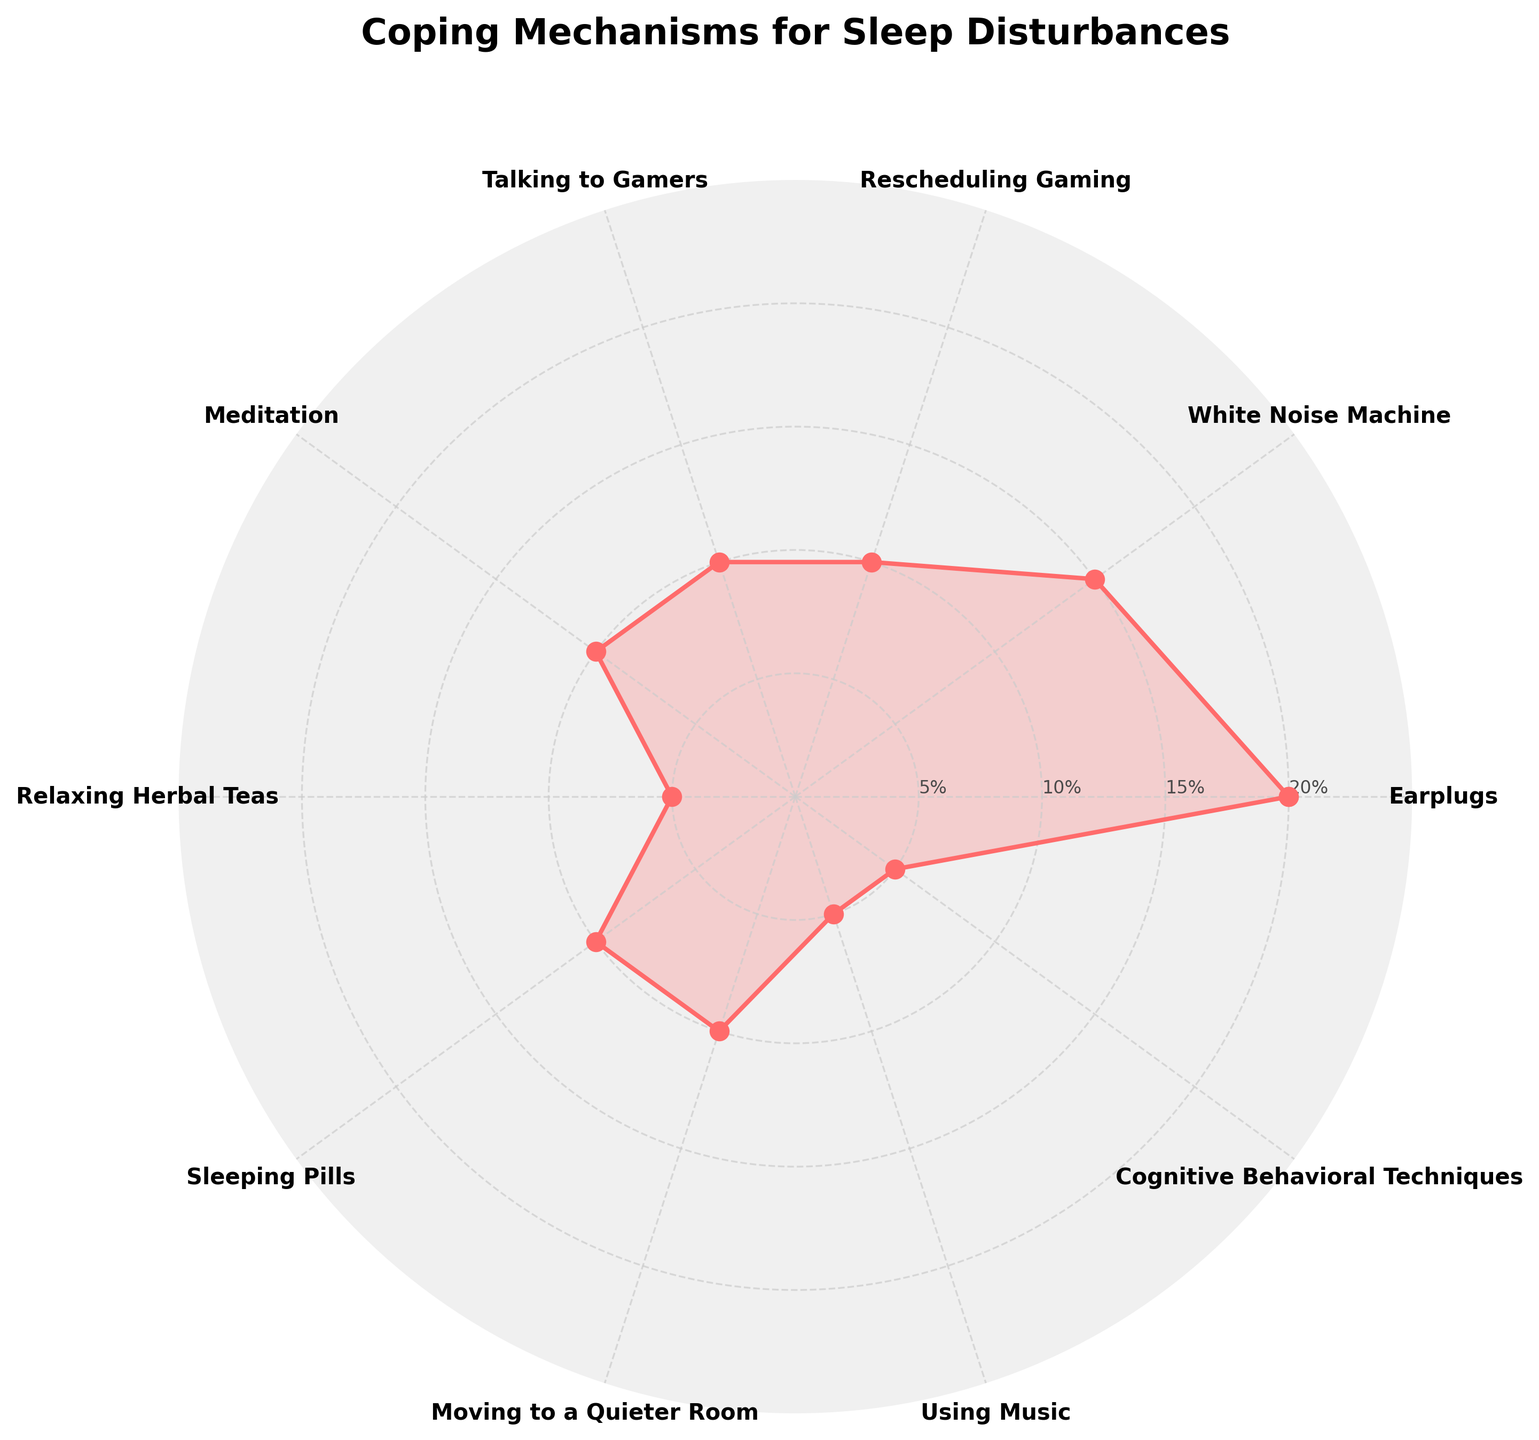What is the title of the chart? The title is typically placed at the top of the chart in a larger font. Reading it directly can provide this information.
Answer: Coping Mechanisms for Sleep Disturbances How many coping mechanisms are listed? The chart lists each coping mechanism around the polar plot area. Counting each labeled category directly answers this question.
Answer: 10 What coping mechanism has the highest percentage? Looking at the data points on the chart's outermost ring shows which coping mechanism reaches the highest value.
Answer: Earplugs Which coping mechanisms have a percentage of 10%? By checking the radial position where values intersect the 10% ring, we identify the corresponding categories.
Answer: Rescheduling Gaming, Talking to Gamers, Meditation, Sleeping Pills, Moving to a Quieter Room What is the combined percentage for White Noise Machine and Meditation? Adding percentages from the chart for White Noise Machine (15%) and Meditation (10%).
Answer: 25% Which coping mechanism is more commonly used: Rescheduling Gaming or Using Music? Comparing the percentage values, Rescheduling Gaming is 10%, and Using Music is 5%, indicating which is greater.
Answer: Rescheduling Gaming What is the average percentage of all coping mechanisms? Summing all the percentage values and then dividing by the number of coping mechanisms (10). (20+15+10+10+10+5+10+10+5+5)/10 = 100/10 = 10.
Answer: 10% What coping mechanisms fall into the range of 5% to 10%? Reviewing each category plotted within this range of radial values identifies the relevant coping mechanisms.
Answer: Meditation, Relaxing Herbal Teas, Sleeping Pills, Moving to a Quieter Room, Using Music, Cognitive Behavioral Techniques Which coping mechanisms have an equal percentage? Observing the chart for equal-length radial lines, we can match percentages for verification.
Answer: Rescheduling Gaming, Talking to Gamers, Meditation, Sleeping Pills, Moving to a Quieter Room all have 10% What percentage ranges are used for the radial ticks or labels? Looking at the concentric rings marked with percentage values answers this question.
Answer: 5%, 10%, 15%, 20% 